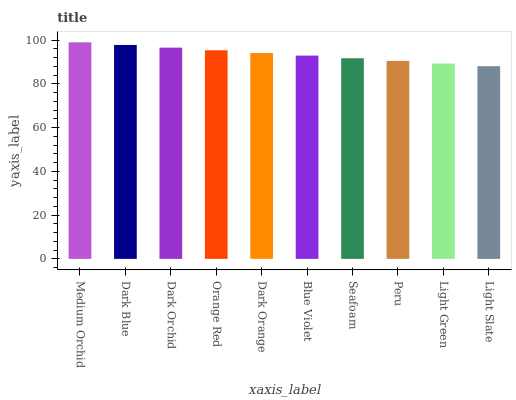Is Light Slate the minimum?
Answer yes or no. Yes. Is Medium Orchid the maximum?
Answer yes or no. Yes. Is Dark Blue the minimum?
Answer yes or no. No. Is Dark Blue the maximum?
Answer yes or no. No. Is Medium Orchid greater than Dark Blue?
Answer yes or no. Yes. Is Dark Blue less than Medium Orchid?
Answer yes or no. Yes. Is Dark Blue greater than Medium Orchid?
Answer yes or no. No. Is Medium Orchid less than Dark Blue?
Answer yes or no. No. Is Dark Orange the high median?
Answer yes or no. Yes. Is Blue Violet the low median?
Answer yes or no. Yes. Is Blue Violet the high median?
Answer yes or no. No. Is Medium Orchid the low median?
Answer yes or no. No. 